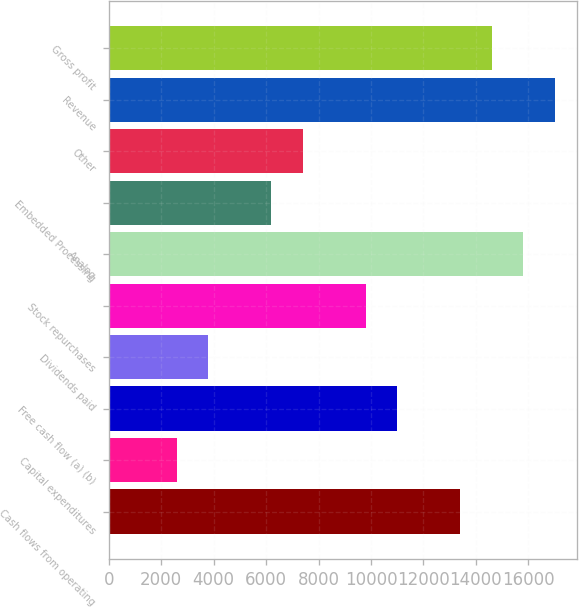<chart> <loc_0><loc_0><loc_500><loc_500><bar_chart><fcel>Cash flows from operating<fcel>Capital expenditures<fcel>Free cash flow (a) (b)<fcel>Dividends paid<fcel>Stock repurchases<fcel>Analog<fcel>Embedded Processing<fcel>Other<fcel>Revenue<fcel>Gross profit<nl><fcel>13406.6<fcel>2592.2<fcel>11003.4<fcel>3793.8<fcel>9801.8<fcel>15809.8<fcel>6197<fcel>7398.6<fcel>17011.4<fcel>14608.2<nl></chart> 